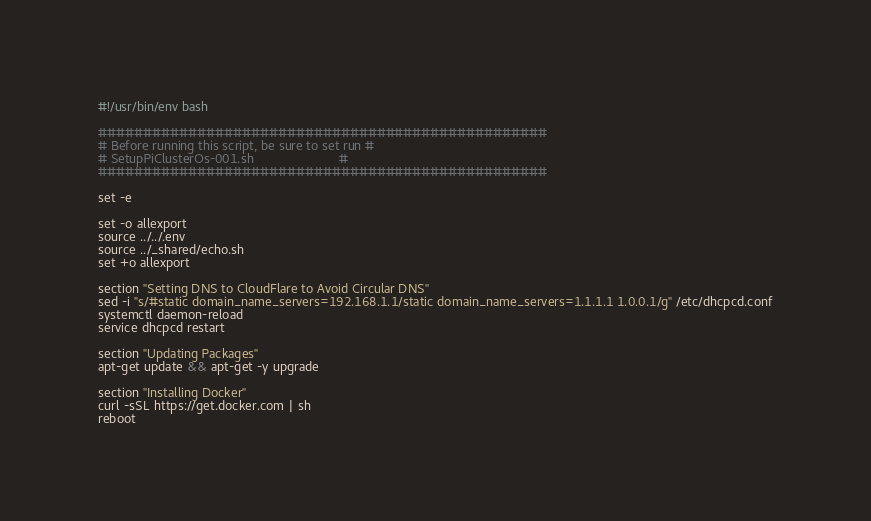Convert code to text. <code><loc_0><loc_0><loc_500><loc_500><_Bash_>#!/usr/bin/env bash

##################################################
# Before running this script, be sure to set run #
# SetupPiClusterOs-001.sh                        #
##################################################

set -e

set -o allexport
source ../../.env
source ../_shared/echo.sh
set +o allexport

section "Setting DNS to CloudFlare to Avoid Circular DNS"
sed -i "s/#static domain_name_servers=192.168.1.1/static domain_name_servers=1.1.1.1 1.0.0.1/g" /etc/dhcpcd.conf
systemctl daemon-reload
service dhcpcd restart

section "Updating Packages"
apt-get update && apt-get -y upgrade

section "Installing Docker"
curl -sSL https://get.docker.com | sh
reboot
</code> 